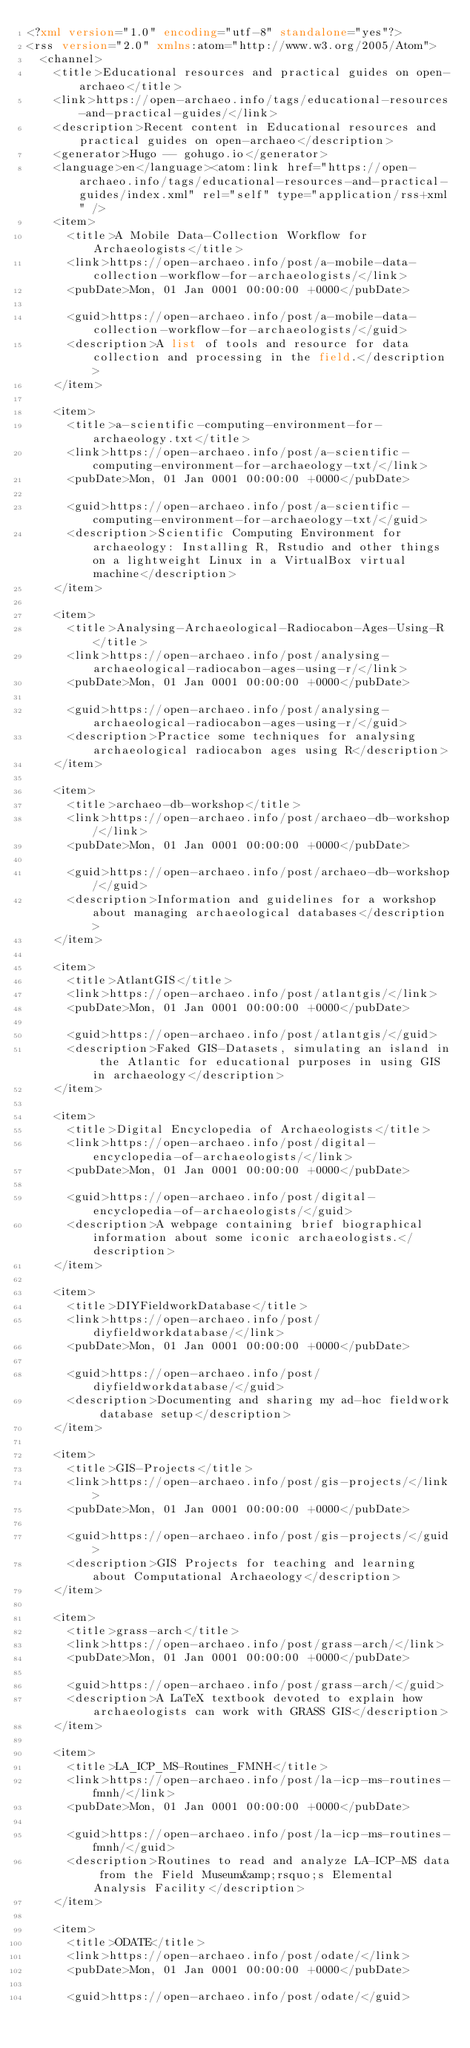Convert code to text. <code><loc_0><loc_0><loc_500><loc_500><_XML_><?xml version="1.0" encoding="utf-8" standalone="yes"?>
<rss version="2.0" xmlns:atom="http://www.w3.org/2005/Atom">
  <channel>
    <title>Educational resources and practical guides on open-archaeo</title>
    <link>https://open-archaeo.info/tags/educational-resources-and-practical-guides/</link>
    <description>Recent content in Educational resources and practical guides on open-archaeo</description>
    <generator>Hugo -- gohugo.io</generator>
    <language>en</language><atom:link href="https://open-archaeo.info/tags/educational-resources-and-practical-guides/index.xml" rel="self" type="application/rss+xml" />
    <item>
      <title>A Mobile Data-Collection Workflow for Archaeologists</title>
      <link>https://open-archaeo.info/post/a-mobile-data-collection-workflow-for-archaeologists/</link>
      <pubDate>Mon, 01 Jan 0001 00:00:00 +0000</pubDate>
      
      <guid>https://open-archaeo.info/post/a-mobile-data-collection-workflow-for-archaeologists/</guid>
      <description>A list of tools and resource for data collection and processing in the field.</description>
    </item>
    
    <item>
      <title>a-scientific-computing-environment-for-archaeology.txt</title>
      <link>https://open-archaeo.info/post/a-scientific-computing-environment-for-archaeology-txt/</link>
      <pubDate>Mon, 01 Jan 0001 00:00:00 +0000</pubDate>
      
      <guid>https://open-archaeo.info/post/a-scientific-computing-environment-for-archaeology-txt/</guid>
      <description>Scientific Computing Environment for archaeology: Installing R, Rstudio and other things on a lightweight Linux in a VirtualBox virtual machine</description>
    </item>
    
    <item>
      <title>Analysing-Archaeological-Radiocabon-Ages-Using-R</title>
      <link>https://open-archaeo.info/post/analysing-archaeological-radiocabon-ages-using-r/</link>
      <pubDate>Mon, 01 Jan 0001 00:00:00 +0000</pubDate>
      
      <guid>https://open-archaeo.info/post/analysing-archaeological-radiocabon-ages-using-r/</guid>
      <description>Practice some techniques for analysing archaeological radiocabon ages using R</description>
    </item>
    
    <item>
      <title>archaeo-db-workshop</title>
      <link>https://open-archaeo.info/post/archaeo-db-workshop/</link>
      <pubDate>Mon, 01 Jan 0001 00:00:00 +0000</pubDate>
      
      <guid>https://open-archaeo.info/post/archaeo-db-workshop/</guid>
      <description>Information and guidelines for a workshop about managing archaeological databases</description>
    </item>
    
    <item>
      <title>AtlantGIS</title>
      <link>https://open-archaeo.info/post/atlantgis/</link>
      <pubDate>Mon, 01 Jan 0001 00:00:00 +0000</pubDate>
      
      <guid>https://open-archaeo.info/post/atlantgis/</guid>
      <description>Faked GIS-Datasets, simulating an island in the Atlantic for educational purposes in using GIS in archaeology</description>
    </item>
    
    <item>
      <title>Digital Encyclopedia of Archaeologists</title>
      <link>https://open-archaeo.info/post/digital-encyclopedia-of-archaeologists/</link>
      <pubDate>Mon, 01 Jan 0001 00:00:00 +0000</pubDate>
      
      <guid>https://open-archaeo.info/post/digital-encyclopedia-of-archaeologists/</guid>
      <description>A webpage containing brief biographical information about some iconic archaeologists.</description>
    </item>
    
    <item>
      <title>DIYFieldworkDatabase</title>
      <link>https://open-archaeo.info/post/diyfieldworkdatabase/</link>
      <pubDate>Mon, 01 Jan 0001 00:00:00 +0000</pubDate>
      
      <guid>https://open-archaeo.info/post/diyfieldworkdatabase/</guid>
      <description>Documenting and sharing my ad-hoc fieldwork database setup</description>
    </item>
    
    <item>
      <title>GIS-Projects</title>
      <link>https://open-archaeo.info/post/gis-projects/</link>
      <pubDate>Mon, 01 Jan 0001 00:00:00 +0000</pubDate>
      
      <guid>https://open-archaeo.info/post/gis-projects/</guid>
      <description>GIS Projects for teaching and learning about Computational Archaeology</description>
    </item>
    
    <item>
      <title>grass-arch</title>
      <link>https://open-archaeo.info/post/grass-arch/</link>
      <pubDate>Mon, 01 Jan 0001 00:00:00 +0000</pubDate>
      
      <guid>https://open-archaeo.info/post/grass-arch/</guid>
      <description>A LaTeX textbook devoted to explain how archaeologists can work with GRASS GIS</description>
    </item>
    
    <item>
      <title>LA_ICP_MS-Routines_FMNH</title>
      <link>https://open-archaeo.info/post/la-icp-ms-routines-fmnh/</link>
      <pubDate>Mon, 01 Jan 0001 00:00:00 +0000</pubDate>
      
      <guid>https://open-archaeo.info/post/la-icp-ms-routines-fmnh/</guid>
      <description>Routines to read and analyze LA-ICP-MS data from the Field Museum&amp;rsquo;s Elemental Analysis Facility</description>
    </item>
    
    <item>
      <title>ODATE</title>
      <link>https://open-archaeo.info/post/odate/</link>
      <pubDate>Mon, 01 Jan 0001 00:00:00 +0000</pubDate>
      
      <guid>https://open-archaeo.info/post/odate/</guid></code> 